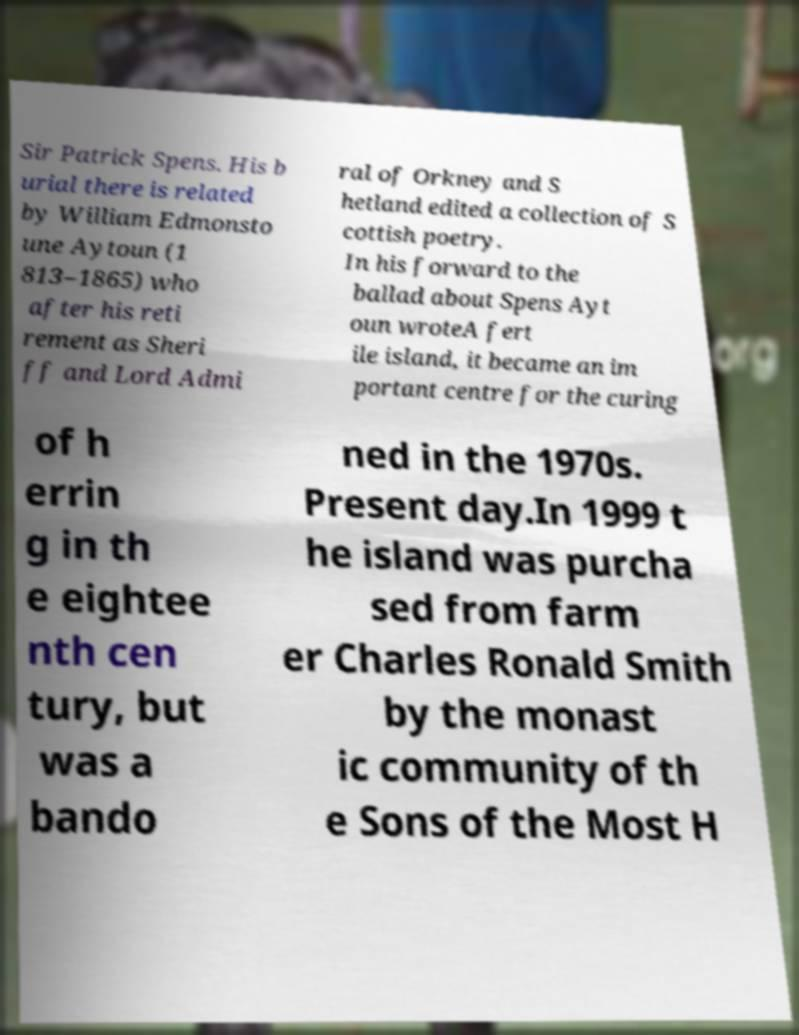Could you extract and type out the text from this image? Sir Patrick Spens. His b urial there is related by William Edmonsto une Aytoun (1 813–1865) who after his reti rement as Sheri ff and Lord Admi ral of Orkney and S hetland edited a collection of S cottish poetry. In his forward to the ballad about Spens Ayt oun wroteA fert ile island, it became an im portant centre for the curing of h errin g in th e eightee nth cen tury, but was a bando ned in the 1970s. Present day.In 1999 t he island was purcha sed from farm er Charles Ronald Smith by the monast ic community of th e Sons of the Most H 